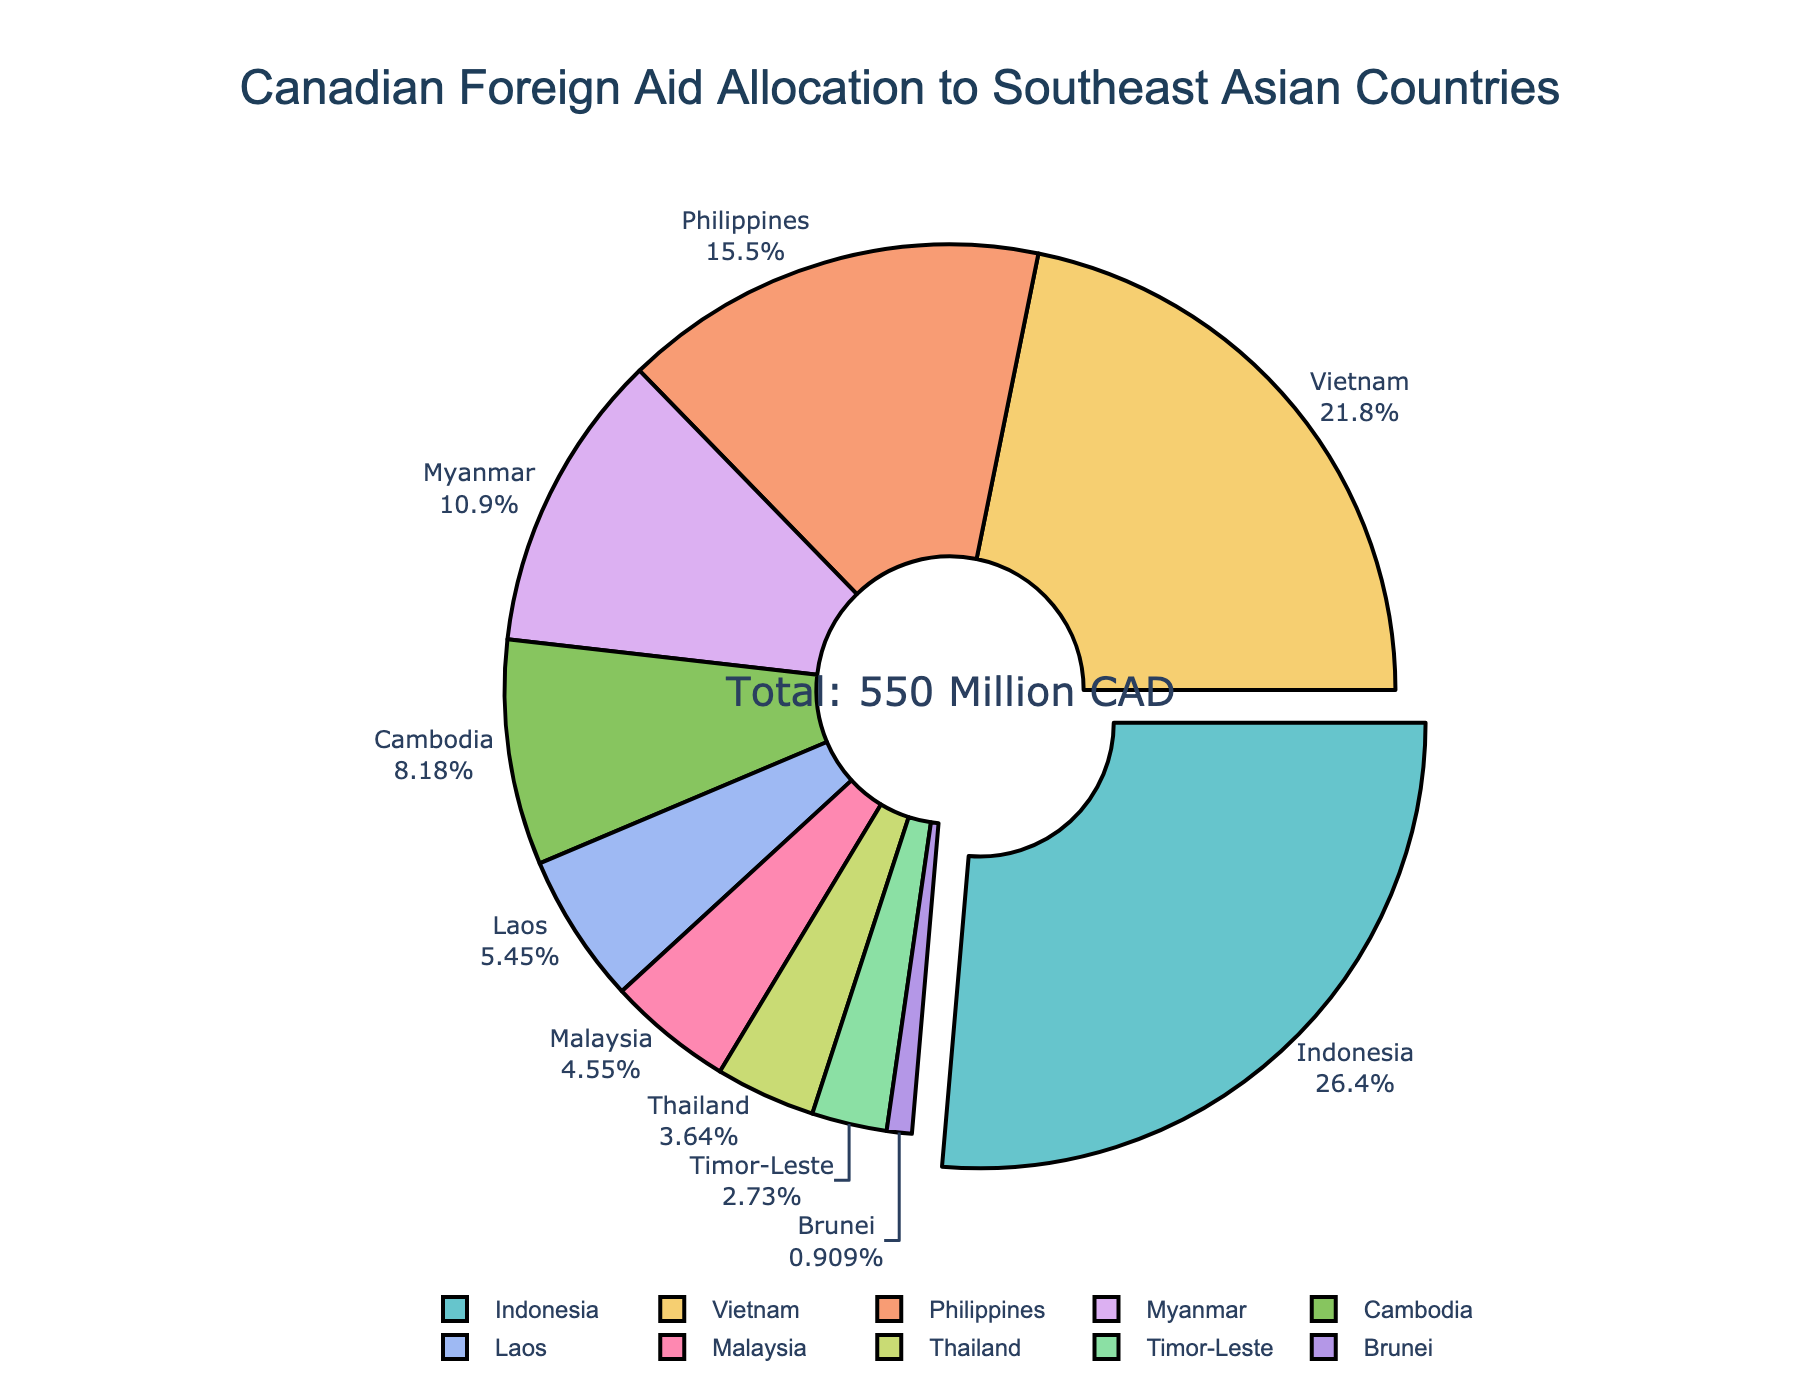What is the title of the plot? The title is often prominently displayed at the top of the plot. In this case, it is located at the center and formatted to stand out.
Answer: Canadian Foreign Aid Allocation to Southeast Asian Countries Which country receives the highest amount of aid? The figure uses a pie chart where the slice pulled out usually indicates the highest value segment. In this chart, the largest colored segment is pulled out slightly.
Answer: Indonesia What percentage of the total aid does Vietnam receive? Look for the label on the pie chart corresponding to Vietnam. Each label outside the pie chart mentions the country along with its percentage of the total aid.
Answer: 18.2% How many countries receive less than 5% of the total aid? The pie chart segments labeled with smaller percentages are those contributing less to the total. Count the number of these labels that show less than 5%.
Answer: 3 What's the total amount of aid distributed among all countries shown in the chart? The chart has an annotation in the middle displaying the total amount, which says "Total: 550 Million CAD".
Answer: 550 Million CAD How much more aid does the Philippines receive compared to Cambodia? To determine this, check the values accompanying the country labels and subtract Cambodia's value from the Philippines'. Philippines receives 85M, Cambodia 45M. So, 85 - 45 = 40.
Answer: 40 Million CAD Which countries receive less aid than Laos? Examine the pie chart segments and their values. Any country segment with a value less than Laos (30 Million CAD) is to be identified.
Answer: Malaysia, Thailand, Timor-Leste, Brunei What is the combined percentage of aid for Thailand and Timor-Leste? Identify the individual percentages for Thailand and Timor-Leste from the chart and add them together. Their labels show 3.6% and 2.7%, respectively. Adding these gives 3.6% + 2.7% = 6.3%.
Answer: 6.3% Which country receives exactly 1.1% of the total aid? Locate the pie chart label showing 1.1%. The label outside the pie chart associated with 1.1% corresponds to Brunei.
Answer: Brunei How does the aid amount for Myanmar compare to Vietnam? Identify the values for both Myanmar and Vietnam from the chart. Myanmar receives 60 Million CAD and Vietnam receives 120 Million CAD, so Myanmar receives half the amount of Vietnam.
Answer: Half 